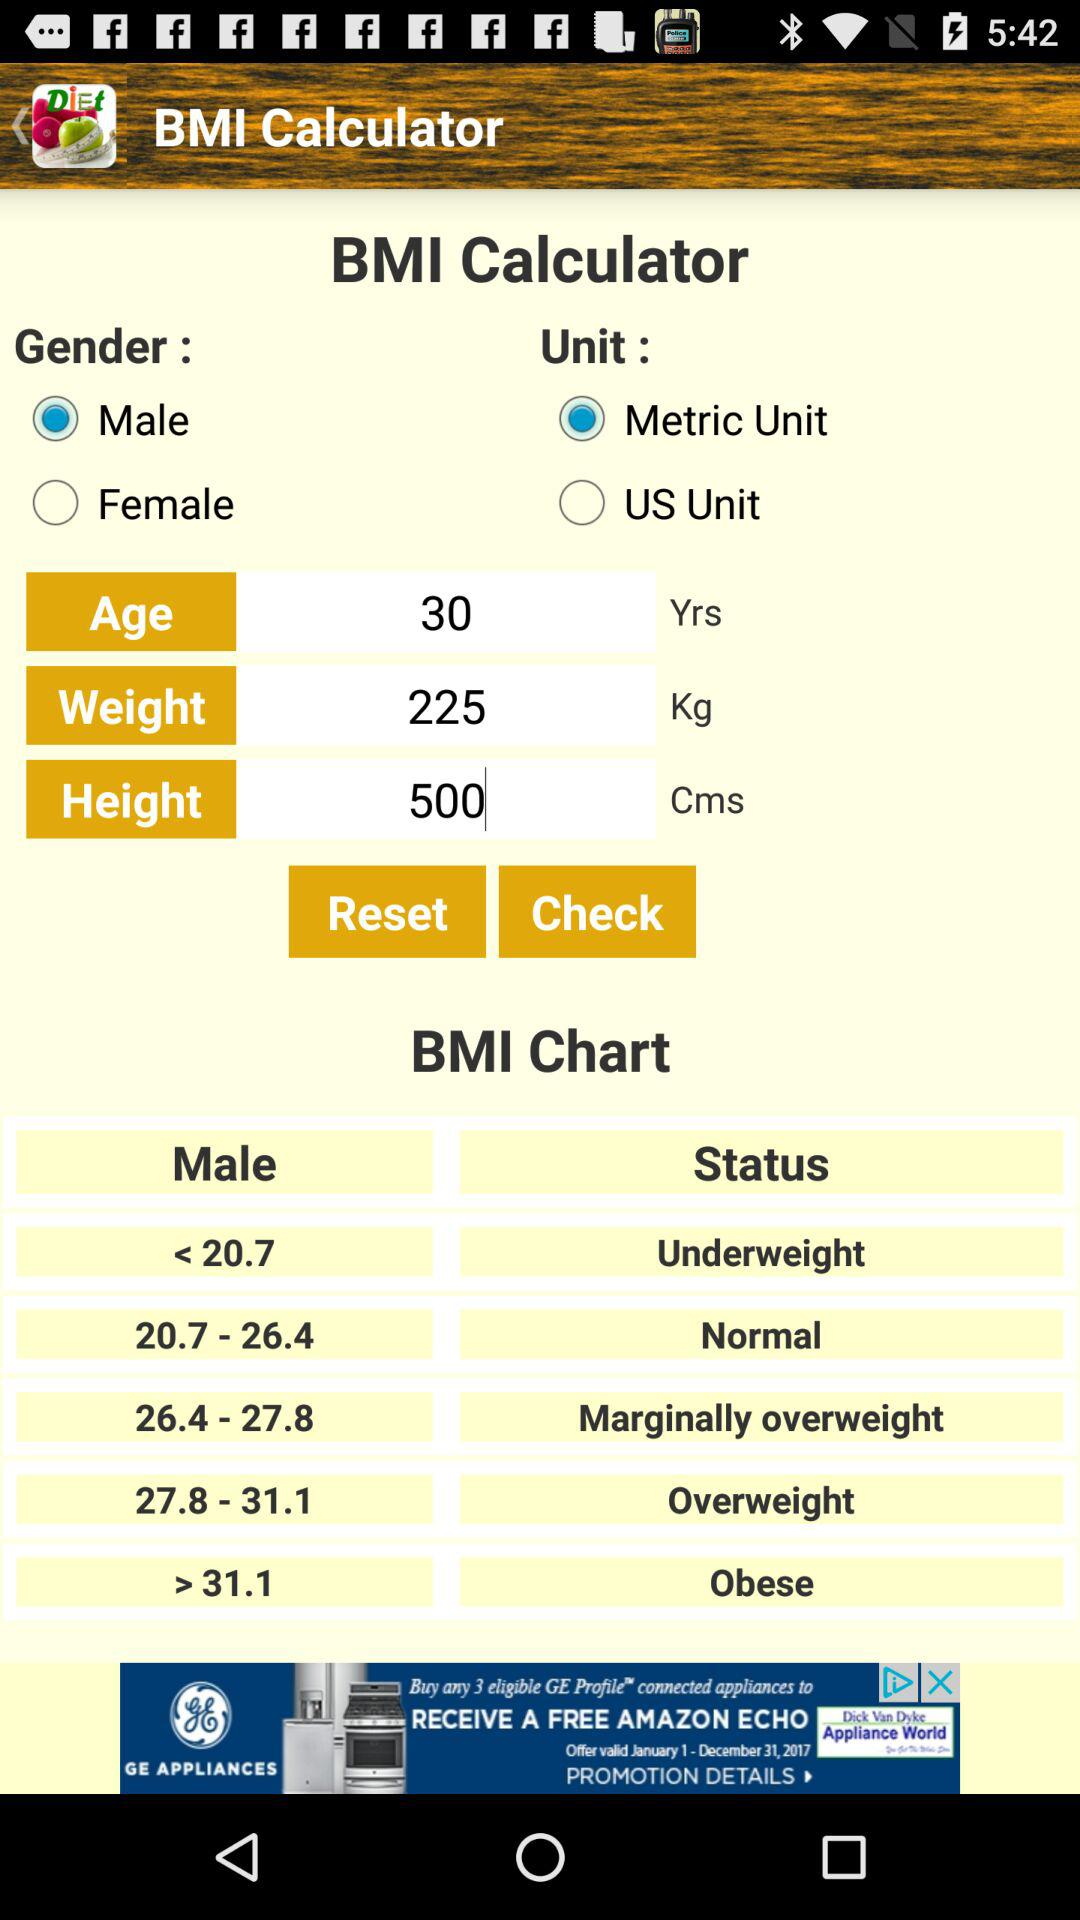How many options are there for the gender?
Answer the question using a single word or phrase. 2 